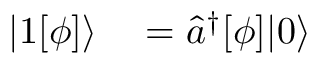Convert formula to latex. <formula><loc_0><loc_0><loc_500><loc_500>\begin{array} { r l } { | 1 [ \phi ] \rangle } & = \hat { a } ^ { \dagger } [ \phi ] | 0 \rangle } \end{array}</formula> 